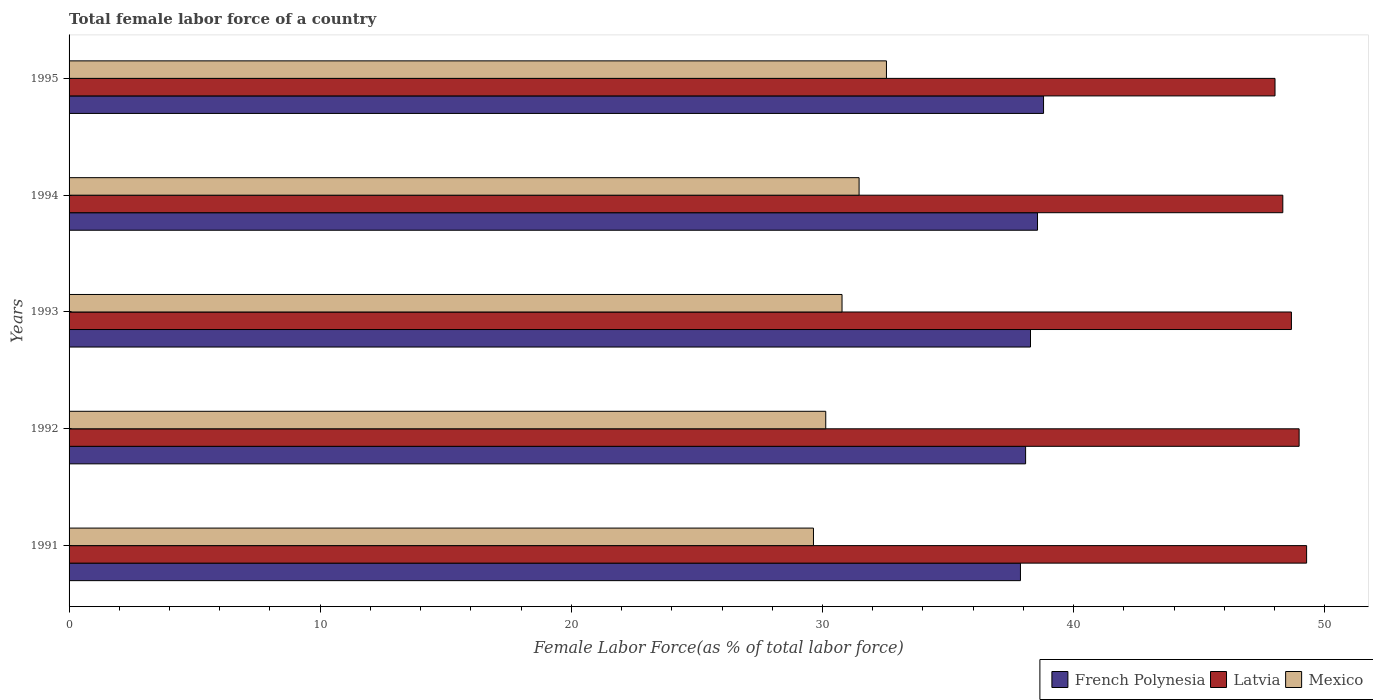Are the number of bars on each tick of the Y-axis equal?
Provide a short and direct response. Yes. How many bars are there on the 3rd tick from the top?
Give a very brief answer. 3. In how many cases, is the number of bars for a given year not equal to the number of legend labels?
Provide a succinct answer. 0. What is the percentage of female labor force in Latvia in 1995?
Make the answer very short. 48.02. Across all years, what is the maximum percentage of female labor force in Mexico?
Your answer should be very brief. 32.55. Across all years, what is the minimum percentage of female labor force in French Polynesia?
Keep it short and to the point. 37.88. In which year was the percentage of female labor force in Latvia maximum?
Make the answer very short. 1991. In which year was the percentage of female labor force in Mexico minimum?
Your response must be concise. 1991. What is the total percentage of female labor force in Latvia in the graph?
Your response must be concise. 243.28. What is the difference between the percentage of female labor force in Mexico in 1993 and that in 1995?
Provide a succinct answer. -1.77. What is the difference between the percentage of female labor force in Latvia in 1993 and the percentage of female labor force in French Polynesia in 1992?
Ensure brevity in your answer.  10.58. What is the average percentage of female labor force in Mexico per year?
Ensure brevity in your answer.  30.91. In the year 1995, what is the difference between the percentage of female labor force in Mexico and percentage of female labor force in French Polynesia?
Your answer should be compact. -6.26. What is the ratio of the percentage of female labor force in Mexico in 1991 to that in 1994?
Provide a succinct answer. 0.94. Is the percentage of female labor force in Mexico in 1994 less than that in 1995?
Offer a very short reply. Yes. Is the difference between the percentage of female labor force in Mexico in 1991 and 1993 greater than the difference between the percentage of female labor force in French Polynesia in 1991 and 1993?
Make the answer very short. No. What is the difference between the highest and the second highest percentage of female labor force in Mexico?
Provide a succinct answer. 1.09. What is the difference between the highest and the lowest percentage of female labor force in Mexico?
Your response must be concise. 2.91. In how many years, is the percentage of female labor force in French Polynesia greater than the average percentage of female labor force in French Polynesia taken over all years?
Your answer should be very brief. 2. Is the sum of the percentage of female labor force in Mexico in 1992 and 1993 greater than the maximum percentage of female labor force in Latvia across all years?
Give a very brief answer. Yes. What does the 2nd bar from the top in 1995 represents?
Give a very brief answer. Latvia. What does the 1st bar from the bottom in 1991 represents?
Offer a terse response. French Polynesia. Is it the case that in every year, the sum of the percentage of female labor force in Mexico and percentage of female labor force in French Polynesia is greater than the percentage of female labor force in Latvia?
Offer a very short reply. Yes. How many bars are there?
Ensure brevity in your answer.  15. How many years are there in the graph?
Your response must be concise. 5. What is the difference between two consecutive major ticks on the X-axis?
Provide a succinct answer. 10. Are the values on the major ticks of X-axis written in scientific E-notation?
Your answer should be compact. No. Does the graph contain any zero values?
Keep it short and to the point. No. How many legend labels are there?
Provide a short and direct response. 3. How are the legend labels stacked?
Make the answer very short. Horizontal. What is the title of the graph?
Give a very brief answer. Total female labor force of a country. Does "Turkmenistan" appear as one of the legend labels in the graph?
Keep it short and to the point. No. What is the label or title of the X-axis?
Provide a succinct answer. Female Labor Force(as % of total labor force). What is the Female Labor Force(as % of total labor force) of French Polynesia in 1991?
Ensure brevity in your answer.  37.88. What is the Female Labor Force(as % of total labor force) in Latvia in 1991?
Offer a very short reply. 49.28. What is the Female Labor Force(as % of total labor force) in Mexico in 1991?
Provide a short and direct response. 29.64. What is the Female Labor Force(as % of total labor force) in French Polynesia in 1992?
Ensure brevity in your answer.  38.09. What is the Female Labor Force(as % of total labor force) in Latvia in 1992?
Provide a short and direct response. 48.98. What is the Female Labor Force(as % of total labor force) of Mexico in 1992?
Your answer should be compact. 30.13. What is the Female Labor Force(as % of total labor force) of French Polynesia in 1993?
Your answer should be very brief. 38.28. What is the Female Labor Force(as % of total labor force) in Latvia in 1993?
Give a very brief answer. 48.67. What is the Female Labor Force(as % of total labor force) in Mexico in 1993?
Offer a very short reply. 30.78. What is the Female Labor Force(as % of total labor force) in French Polynesia in 1994?
Your answer should be compact. 38.56. What is the Female Labor Force(as % of total labor force) of Latvia in 1994?
Keep it short and to the point. 48.33. What is the Female Labor Force(as % of total labor force) in Mexico in 1994?
Ensure brevity in your answer.  31.46. What is the Female Labor Force(as % of total labor force) in French Polynesia in 1995?
Keep it short and to the point. 38.8. What is the Female Labor Force(as % of total labor force) in Latvia in 1995?
Your answer should be compact. 48.02. What is the Female Labor Force(as % of total labor force) of Mexico in 1995?
Your response must be concise. 32.55. Across all years, what is the maximum Female Labor Force(as % of total labor force) of French Polynesia?
Give a very brief answer. 38.8. Across all years, what is the maximum Female Labor Force(as % of total labor force) in Latvia?
Your answer should be very brief. 49.28. Across all years, what is the maximum Female Labor Force(as % of total labor force) in Mexico?
Give a very brief answer. 32.55. Across all years, what is the minimum Female Labor Force(as % of total labor force) of French Polynesia?
Your response must be concise. 37.88. Across all years, what is the minimum Female Labor Force(as % of total labor force) of Latvia?
Provide a short and direct response. 48.02. Across all years, what is the minimum Female Labor Force(as % of total labor force) in Mexico?
Give a very brief answer. 29.64. What is the total Female Labor Force(as % of total labor force) of French Polynesia in the graph?
Your response must be concise. 191.62. What is the total Female Labor Force(as % of total labor force) in Latvia in the graph?
Make the answer very short. 243.28. What is the total Female Labor Force(as % of total labor force) in Mexico in the graph?
Give a very brief answer. 154.55. What is the difference between the Female Labor Force(as % of total labor force) of French Polynesia in 1991 and that in 1992?
Keep it short and to the point. -0.21. What is the difference between the Female Labor Force(as % of total labor force) of Latvia in 1991 and that in 1992?
Ensure brevity in your answer.  0.3. What is the difference between the Female Labor Force(as % of total labor force) in Mexico in 1991 and that in 1992?
Ensure brevity in your answer.  -0.49. What is the difference between the Female Labor Force(as % of total labor force) of Latvia in 1991 and that in 1993?
Offer a terse response. 0.6. What is the difference between the Female Labor Force(as % of total labor force) in Mexico in 1991 and that in 1993?
Your response must be concise. -1.14. What is the difference between the Female Labor Force(as % of total labor force) of French Polynesia in 1991 and that in 1994?
Give a very brief answer. -0.68. What is the difference between the Female Labor Force(as % of total labor force) in Latvia in 1991 and that in 1994?
Ensure brevity in your answer.  0.95. What is the difference between the Female Labor Force(as % of total labor force) in Mexico in 1991 and that in 1994?
Provide a succinct answer. -1.82. What is the difference between the Female Labor Force(as % of total labor force) in French Polynesia in 1991 and that in 1995?
Make the answer very short. -0.92. What is the difference between the Female Labor Force(as % of total labor force) in Latvia in 1991 and that in 1995?
Ensure brevity in your answer.  1.26. What is the difference between the Female Labor Force(as % of total labor force) in Mexico in 1991 and that in 1995?
Offer a very short reply. -2.91. What is the difference between the Female Labor Force(as % of total labor force) of French Polynesia in 1992 and that in 1993?
Provide a short and direct response. -0.19. What is the difference between the Female Labor Force(as % of total labor force) in Latvia in 1992 and that in 1993?
Provide a succinct answer. 0.31. What is the difference between the Female Labor Force(as % of total labor force) in Mexico in 1992 and that in 1993?
Make the answer very short. -0.65. What is the difference between the Female Labor Force(as % of total labor force) of French Polynesia in 1992 and that in 1994?
Give a very brief answer. -0.47. What is the difference between the Female Labor Force(as % of total labor force) in Latvia in 1992 and that in 1994?
Provide a succinct answer. 0.65. What is the difference between the Female Labor Force(as % of total labor force) of Mexico in 1992 and that in 1994?
Make the answer very short. -1.33. What is the difference between the Female Labor Force(as % of total labor force) in French Polynesia in 1992 and that in 1995?
Provide a succinct answer. -0.71. What is the difference between the Female Labor Force(as % of total labor force) of Mexico in 1992 and that in 1995?
Give a very brief answer. -2.42. What is the difference between the Female Labor Force(as % of total labor force) of French Polynesia in 1993 and that in 1994?
Offer a terse response. -0.28. What is the difference between the Female Labor Force(as % of total labor force) in Latvia in 1993 and that in 1994?
Give a very brief answer. 0.34. What is the difference between the Female Labor Force(as % of total labor force) in Mexico in 1993 and that in 1994?
Offer a very short reply. -0.68. What is the difference between the Female Labor Force(as % of total labor force) in French Polynesia in 1993 and that in 1995?
Offer a terse response. -0.52. What is the difference between the Female Labor Force(as % of total labor force) in Latvia in 1993 and that in 1995?
Make the answer very short. 0.65. What is the difference between the Female Labor Force(as % of total labor force) in Mexico in 1993 and that in 1995?
Offer a terse response. -1.77. What is the difference between the Female Labor Force(as % of total labor force) of French Polynesia in 1994 and that in 1995?
Offer a very short reply. -0.24. What is the difference between the Female Labor Force(as % of total labor force) in Latvia in 1994 and that in 1995?
Keep it short and to the point. 0.31. What is the difference between the Female Labor Force(as % of total labor force) of Mexico in 1994 and that in 1995?
Your answer should be compact. -1.09. What is the difference between the Female Labor Force(as % of total labor force) in French Polynesia in 1991 and the Female Labor Force(as % of total labor force) in Latvia in 1992?
Give a very brief answer. -11.1. What is the difference between the Female Labor Force(as % of total labor force) in French Polynesia in 1991 and the Female Labor Force(as % of total labor force) in Mexico in 1992?
Provide a succinct answer. 7.75. What is the difference between the Female Labor Force(as % of total labor force) in Latvia in 1991 and the Female Labor Force(as % of total labor force) in Mexico in 1992?
Your answer should be compact. 19.15. What is the difference between the Female Labor Force(as % of total labor force) of French Polynesia in 1991 and the Female Labor Force(as % of total labor force) of Latvia in 1993?
Keep it short and to the point. -10.79. What is the difference between the Female Labor Force(as % of total labor force) in French Polynesia in 1991 and the Female Labor Force(as % of total labor force) in Mexico in 1993?
Provide a short and direct response. 7.1. What is the difference between the Female Labor Force(as % of total labor force) of Latvia in 1991 and the Female Labor Force(as % of total labor force) of Mexico in 1993?
Make the answer very short. 18.5. What is the difference between the Female Labor Force(as % of total labor force) of French Polynesia in 1991 and the Female Labor Force(as % of total labor force) of Latvia in 1994?
Offer a terse response. -10.45. What is the difference between the Female Labor Force(as % of total labor force) in French Polynesia in 1991 and the Female Labor Force(as % of total labor force) in Mexico in 1994?
Keep it short and to the point. 6.42. What is the difference between the Female Labor Force(as % of total labor force) in Latvia in 1991 and the Female Labor Force(as % of total labor force) in Mexico in 1994?
Ensure brevity in your answer.  17.82. What is the difference between the Female Labor Force(as % of total labor force) in French Polynesia in 1991 and the Female Labor Force(as % of total labor force) in Latvia in 1995?
Keep it short and to the point. -10.14. What is the difference between the Female Labor Force(as % of total labor force) of French Polynesia in 1991 and the Female Labor Force(as % of total labor force) of Mexico in 1995?
Ensure brevity in your answer.  5.34. What is the difference between the Female Labor Force(as % of total labor force) of Latvia in 1991 and the Female Labor Force(as % of total labor force) of Mexico in 1995?
Keep it short and to the point. 16.73. What is the difference between the Female Labor Force(as % of total labor force) of French Polynesia in 1992 and the Female Labor Force(as % of total labor force) of Latvia in 1993?
Your answer should be very brief. -10.58. What is the difference between the Female Labor Force(as % of total labor force) of French Polynesia in 1992 and the Female Labor Force(as % of total labor force) of Mexico in 1993?
Offer a very short reply. 7.31. What is the difference between the Female Labor Force(as % of total labor force) of Latvia in 1992 and the Female Labor Force(as % of total labor force) of Mexico in 1993?
Your answer should be compact. 18.2. What is the difference between the Female Labor Force(as % of total labor force) in French Polynesia in 1992 and the Female Labor Force(as % of total labor force) in Latvia in 1994?
Offer a terse response. -10.24. What is the difference between the Female Labor Force(as % of total labor force) in French Polynesia in 1992 and the Female Labor Force(as % of total labor force) in Mexico in 1994?
Make the answer very short. 6.63. What is the difference between the Female Labor Force(as % of total labor force) in Latvia in 1992 and the Female Labor Force(as % of total labor force) in Mexico in 1994?
Make the answer very short. 17.52. What is the difference between the Female Labor Force(as % of total labor force) of French Polynesia in 1992 and the Female Labor Force(as % of total labor force) of Latvia in 1995?
Make the answer very short. -9.93. What is the difference between the Female Labor Force(as % of total labor force) of French Polynesia in 1992 and the Female Labor Force(as % of total labor force) of Mexico in 1995?
Offer a terse response. 5.54. What is the difference between the Female Labor Force(as % of total labor force) in Latvia in 1992 and the Female Labor Force(as % of total labor force) in Mexico in 1995?
Provide a short and direct response. 16.43. What is the difference between the Female Labor Force(as % of total labor force) in French Polynesia in 1993 and the Female Labor Force(as % of total labor force) in Latvia in 1994?
Give a very brief answer. -10.05. What is the difference between the Female Labor Force(as % of total labor force) of French Polynesia in 1993 and the Female Labor Force(as % of total labor force) of Mexico in 1994?
Provide a short and direct response. 6.83. What is the difference between the Female Labor Force(as % of total labor force) in Latvia in 1993 and the Female Labor Force(as % of total labor force) in Mexico in 1994?
Keep it short and to the point. 17.21. What is the difference between the Female Labor Force(as % of total labor force) in French Polynesia in 1993 and the Female Labor Force(as % of total labor force) in Latvia in 1995?
Make the answer very short. -9.74. What is the difference between the Female Labor Force(as % of total labor force) in French Polynesia in 1993 and the Female Labor Force(as % of total labor force) in Mexico in 1995?
Your response must be concise. 5.74. What is the difference between the Female Labor Force(as % of total labor force) in Latvia in 1993 and the Female Labor Force(as % of total labor force) in Mexico in 1995?
Keep it short and to the point. 16.13. What is the difference between the Female Labor Force(as % of total labor force) in French Polynesia in 1994 and the Female Labor Force(as % of total labor force) in Latvia in 1995?
Your answer should be compact. -9.46. What is the difference between the Female Labor Force(as % of total labor force) of French Polynesia in 1994 and the Female Labor Force(as % of total labor force) of Mexico in 1995?
Offer a very short reply. 6.02. What is the difference between the Female Labor Force(as % of total labor force) in Latvia in 1994 and the Female Labor Force(as % of total labor force) in Mexico in 1995?
Give a very brief answer. 15.78. What is the average Female Labor Force(as % of total labor force) in French Polynesia per year?
Provide a short and direct response. 38.32. What is the average Female Labor Force(as % of total labor force) of Latvia per year?
Offer a very short reply. 48.66. What is the average Female Labor Force(as % of total labor force) of Mexico per year?
Your response must be concise. 30.91. In the year 1991, what is the difference between the Female Labor Force(as % of total labor force) in French Polynesia and Female Labor Force(as % of total labor force) in Latvia?
Make the answer very short. -11.39. In the year 1991, what is the difference between the Female Labor Force(as % of total labor force) in French Polynesia and Female Labor Force(as % of total labor force) in Mexico?
Your answer should be compact. 8.24. In the year 1991, what is the difference between the Female Labor Force(as % of total labor force) of Latvia and Female Labor Force(as % of total labor force) of Mexico?
Offer a terse response. 19.64. In the year 1992, what is the difference between the Female Labor Force(as % of total labor force) of French Polynesia and Female Labor Force(as % of total labor force) of Latvia?
Provide a succinct answer. -10.89. In the year 1992, what is the difference between the Female Labor Force(as % of total labor force) of French Polynesia and Female Labor Force(as % of total labor force) of Mexico?
Your answer should be compact. 7.96. In the year 1992, what is the difference between the Female Labor Force(as % of total labor force) of Latvia and Female Labor Force(as % of total labor force) of Mexico?
Provide a short and direct response. 18.85. In the year 1993, what is the difference between the Female Labor Force(as % of total labor force) of French Polynesia and Female Labor Force(as % of total labor force) of Latvia?
Give a very brief answer. -10.39. In the year 1993, what is the difference between the Female Labor Force(as % of total labor force) of French Polynesia and Female Labor Force(as % of total labor force) of Mexico?
Offer a terse response. 7.5. In the year 1993, what is the difference between the Female Labor Force(as % of total labor force) of Latvia and Female Labor Force(as % of total labor force) of Mexico?
Offer a very short reply. 17.89. In the year 1994, what is the difference between the Female Labor Force(as % of total labor force) of French Polynesia and Female Labor Force(as % of total labor force) of Latvia?
Provide a succinct answer. -9.77. In the year 1994, what is the difference between the Female Labor Force(as % of total labor force) of French Polynesia and Female Labor Force(as % of total labor force) of Mexico?
Offer a very short reply. 7.1. In the year 1994, what is the difference between the Female Labor Force(as % of total labor force) in Latvia and Female Labor Force(as % of total labor force) in Mexico?
Ensure brevity in your answer.  16.87. In the year 1995, what is the difference between the Female Labor Force(as % of total labor force) in French Polynesia and Female Labor Force(as % of total labor force) in Latvia?
Keep it short and to the point. -9.22. In the year 1995, what is the difference between the Female Labor Force(as % of total labor force) in French Polynesia and Female Labor Force(as % of total labor force) in Mexico?
Offer a terse response. 6.26. In the year 1995, what is the difference between the Female Labor Force(as % of total labor force) of Latvia and Female Labor Force(as % of total labor force) of Mexico?
Your response must be concise. 15.47. What is the ratio of the Female Labor Force(as % of total labor force) in French Polynesia in 1991 to that in 1992?
Your answer should be compact. 0.99. What is the ratio of the Female Labor Force(as % of total labor force) in Latvia in 1991 to that in 1992?
Your answer should be compact. 1.01. What is the ratio of the Female Labor Force(as % of total labor force) of Mexico in 1991 to that in 1992?
Ensure brevity in your answer.  0.98. What is the ratio of the Female Labor Force(as % of total labor force) in French Polynesia in 1991 to that in 1993?
Keep it short and to the point. 0.99. What is the ratio of the Female Labor Force(as % of total labor force) in Latvia in 1991 to that in 1993?
Provide a short and direct response. 1.01. What is the ratio of the Female Labor Force(as % of total labor force) in Mexico in 1991 to that in 1993?
Ensure brevity in your answer.  0.96. What is the ratio of the Female Labor Force(as % of total labor force) of French Polynesia in 1991 to that in 1994?
Your answer should be very brief. 0.98. What is the ratio of the Female Labor Force(as % of total labor force) of Latvia in 1991 to that in 1994?
Make the answer very short. 1.02. What is the ratio of the Female Labor Force(as % of total labor force) of Mexico in 1991 to that in 1994?
Keep it short and to the point. 0.94. What is the ratio of the Female Labor Force(as % of total labor force) of French Polynesia in 1991 to that in 1995?
Give a very brief answer. 0.98. What is the ratio of the Female Labor Force(as % of total labor force) of Latvia in 1991 to that in 1995?
Ensure brevity in your answer.  1.03. What is the ratio of the Female Labor Force(as % of total labor force) of Mexico in 1991 to that in 1995?
Offer a terse response. 0.91. What is the ratio of the Female Labor Force(as % of total labor force) in Latvia in 1992 to that in 1993?
Offer a terse response. 1.01. What is the ratio of the Female Labor Force(as % of total labor force) in Mexico in 1992 to that in 1993?
Offer a very short reply. 0.98. What is the ratio of the Female Labor Force(as % of total labor force) in French Polynesia in 1992 to that in 1994?
Ensure brevity in your answer.  0.99. What is the ratio of the Female Labor Force(as % of total labor force) in Latvia in 1992 to that in 1994?
Provide a short and direct response. 1.01. What is the ratio of the Female Labor Force(as % of total labor force) in Mexico in 1992 to that in 1994?
Keep it short and to the point. 0.96. What is the ratio of the Female Labor Force(as % of total labor force) of French Polynesia in 1992 to that in 1995?
Offer a very short reply. 0.98. What is the ratio of the Female Labor Force(as % of total labor force) of Mexico in 1992 to that in 1995?
Your response must be concise. 0.93. What is the ratio of the Female Labor Force(as % of total labor force) in French Polynesia in 1993 to that in 1994?
Your response must be concise. 0.99. What is the ratio of the Female Labor Force(as % of total labor force) in Latvia in 1993 to that in 1994?
Your response must be concise. 1.01. What is the ratio of the Female Labor Force(as % of total labor force) in Mexico in 1993 to that in 1994?
Your response must be concise. 0.98. What is the ratio of the Female Labor Force(as % of total labor force) in French Polynesia in 1993 to that in 1995?
Your answer should be very brief. 0.99. What is the ratio of the Female Labor Force(as % of total labor force) in Latvia in 1993 to that in 1995?
Offer a terse response. 1.01. What is the ratio of the Female Labor Force(as % of total labor force) in Mexico in 1993 to that in 1995?
Offer a terse response. 0.95. What is the ratio of the Female Labor Force(as % of total labor force) of Mexico in 1994 to that in 1995?
Make the answer very short. 0.97. What is the difference between the highest and the second highest Female Labor Force(as % of total labor force) in French Polynesia?
Make the answer very short. 0.24. What is the difference between the highest and the second highest Female Labor Force(as % of total labor force) of Latvia?
Provide a short and direct response. 0.3. What is the difference between the highest and the second highest Female Labor Force(as % of total labor force) in Mexico?
Keep it short and to the point. 1.09. What is the difference between the highest and the lowest Female Labor Force(as % of total labor force) in French Polynesia?
Offer a terse response. 0.92. What is the difference between the highest and the lowest Female Labor Force(as % of total labor force) in Latvia?
Ensure brevity in your answer.  1.26. What is the difference between the highest and the lowest Female Labor Force(as % of total labor force) in Mexico?
Provide a succinct answer. 2.91. 